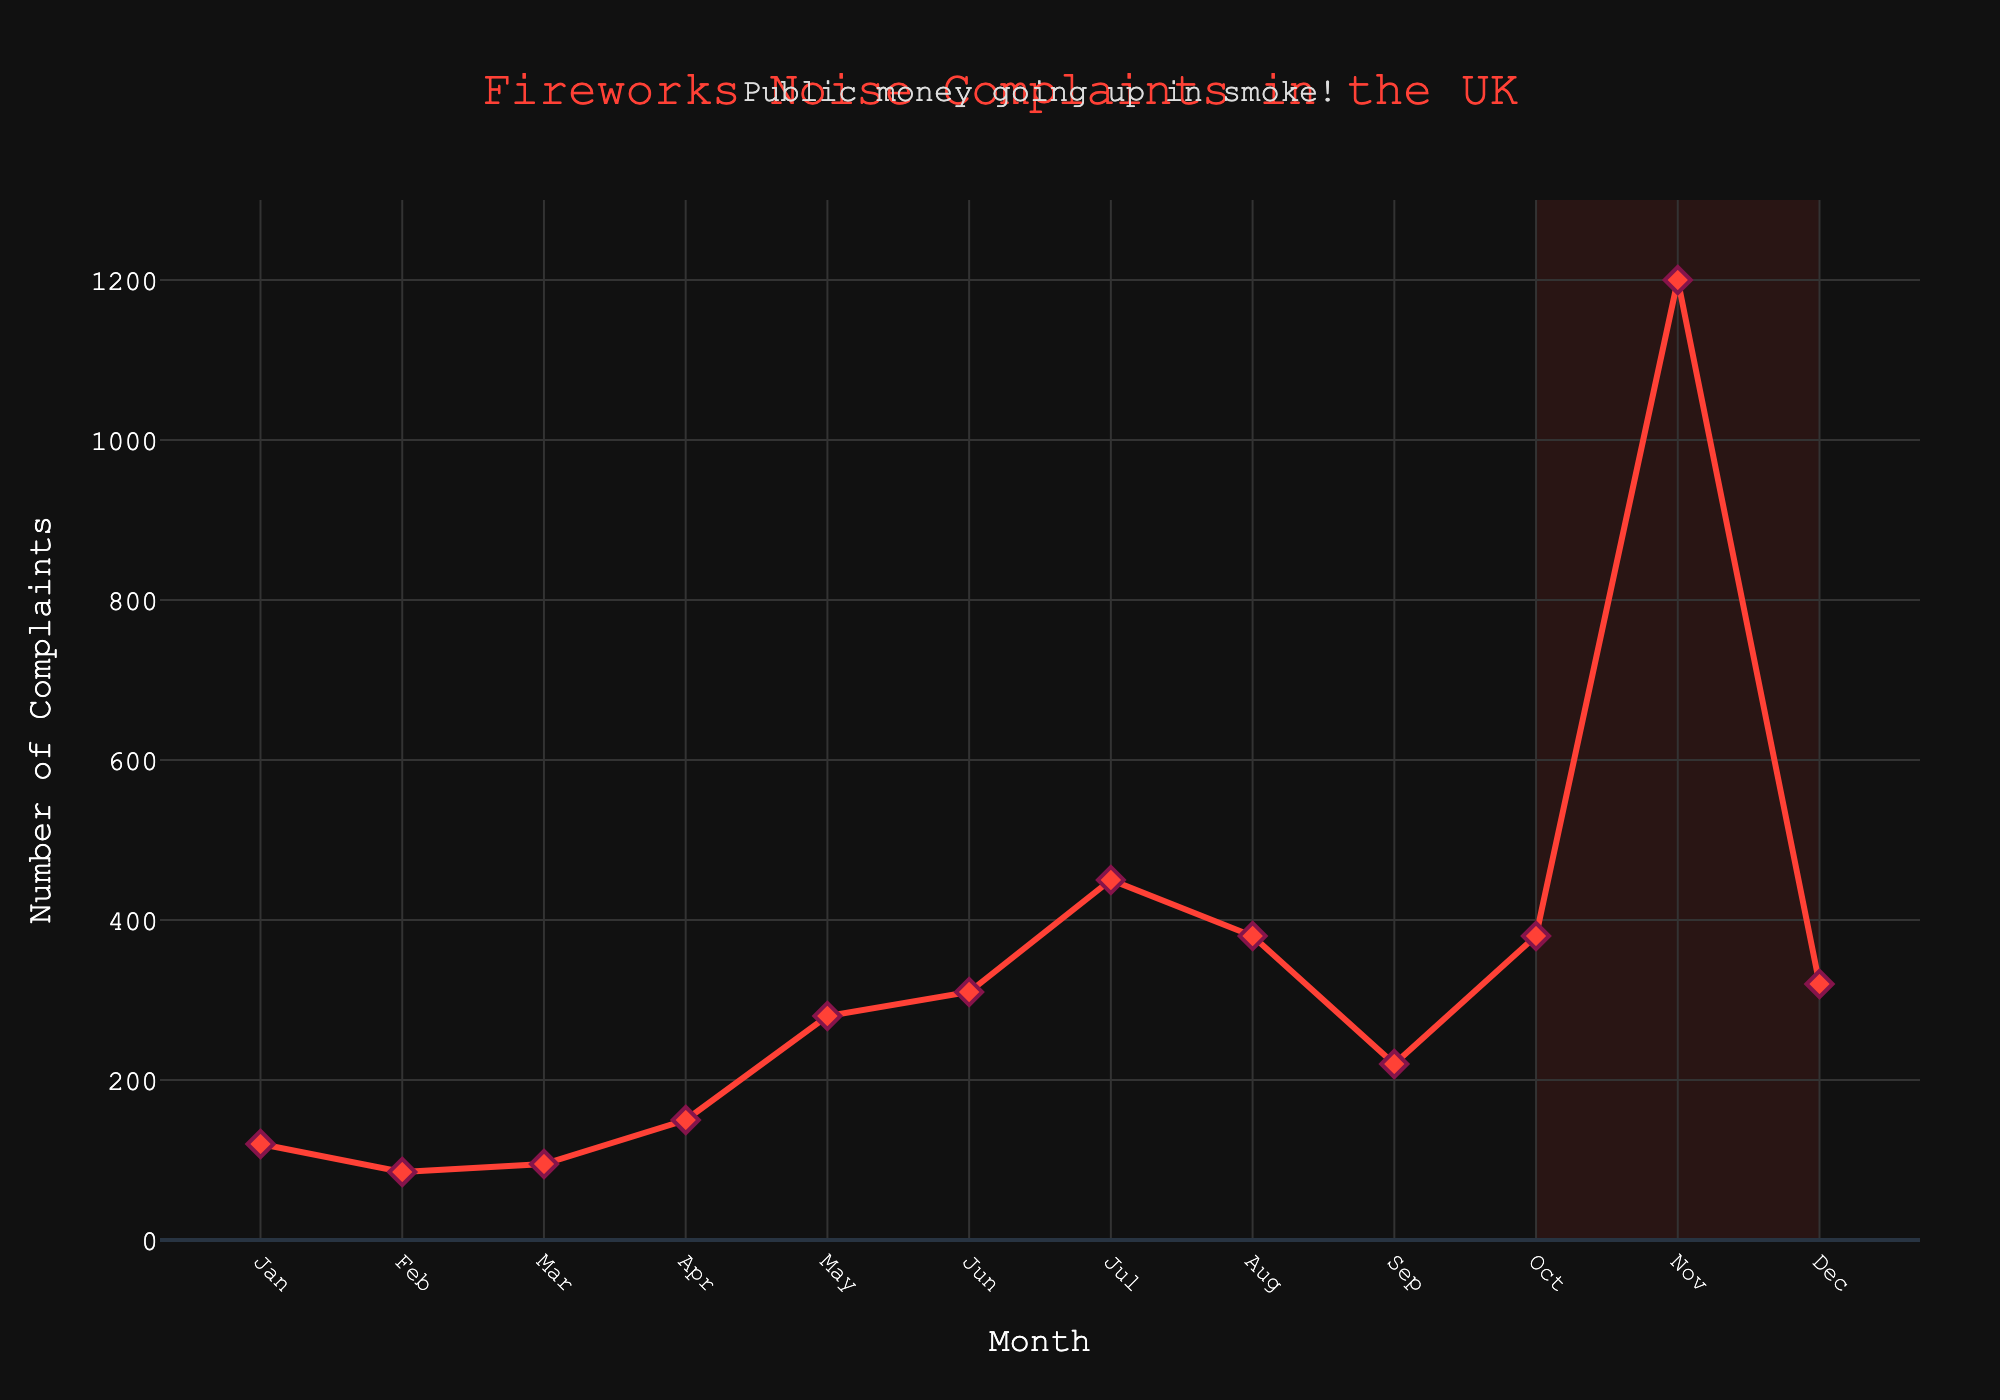Which month had the highest number of noise complaints? Look at the tallest red line with markers chart; November has the highest height, indicating the highest number of complaints.
Answer: November What is the total number of noise complaints from January to June? Sum the values from January to June. 120 (Jan) + 85 (Feb) + 95 (Mar) + 150 (Apr) + 280 (May) + 310 (Jun) = 1040
Answer: 1040 Which month saw a decrease in noise complaints compared to the previous month? Identify months where the line slopes downwards. From July (450 complaints) to August (380 complaints), there is a decrease.
Answer: August What is the average number of noise complaints from May to September? Sum the values from May to September and divide by the number of months. (280 + 310 + 450 + 380 + 220) / 5 = 328
Answer: 328 Is the noise complaint trend increasing, decreasing, or constant from August to October? Observe the line trend from August to October. The line goes up from August (380) to October (380), showing an increasing trend.
Answer: Increasing How many more noise complaints were there in November compared to December? Subtract December's complaints from November's complaints. 1200 (Nov) - 320 (Dec) = 880
Answer: 880 Which months are highlighted by the shaded area in the figure? Identify the shaded area on the x-axis which spans from October to December.
Answer: October to December How does the number of complaints in October compare to that in September? Compare the heights of the markers for October (380) and September (220). October has more complaints.
Answer: October had more complaints What is the trend of noise complaints from February to April? Look at the line chart from February (85) to April (150). The line goes upwards indicating an increasing trend.
Answer: Increasing Which month had the smallest number of noise complaints? Find the shortest line with a marker on the chart, which is February with 85 complaints.
Answer: February 